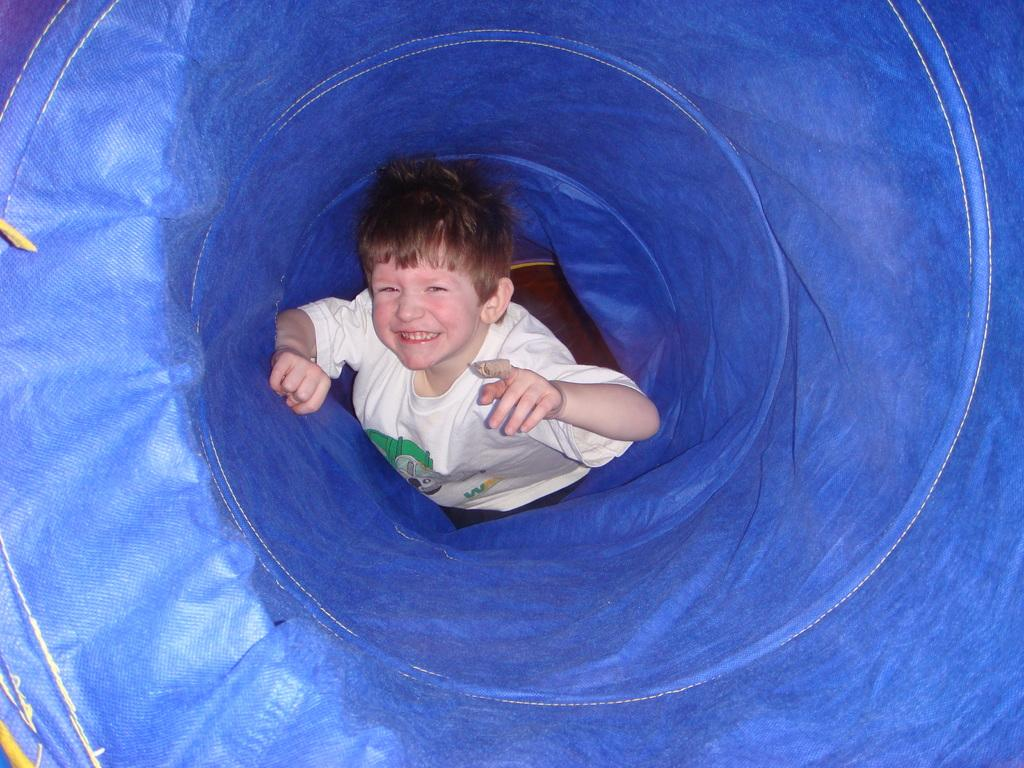Who is the main subject in the image? There is a boy in the image. What is the boy wearing? The boy is wearing a white t-shirt. Where is the boy located in the image? The boy is visible on a blue color container. What type of trade is the boy involved in during the night in the image? There is no indication of trade or nighttime in the image; it simply shows a boy wearing a white t-shirt on a blue color container. 